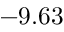<formula> <loc_0><loc_0><loc_500><loc_500>- 9 . 6 3</formula> 